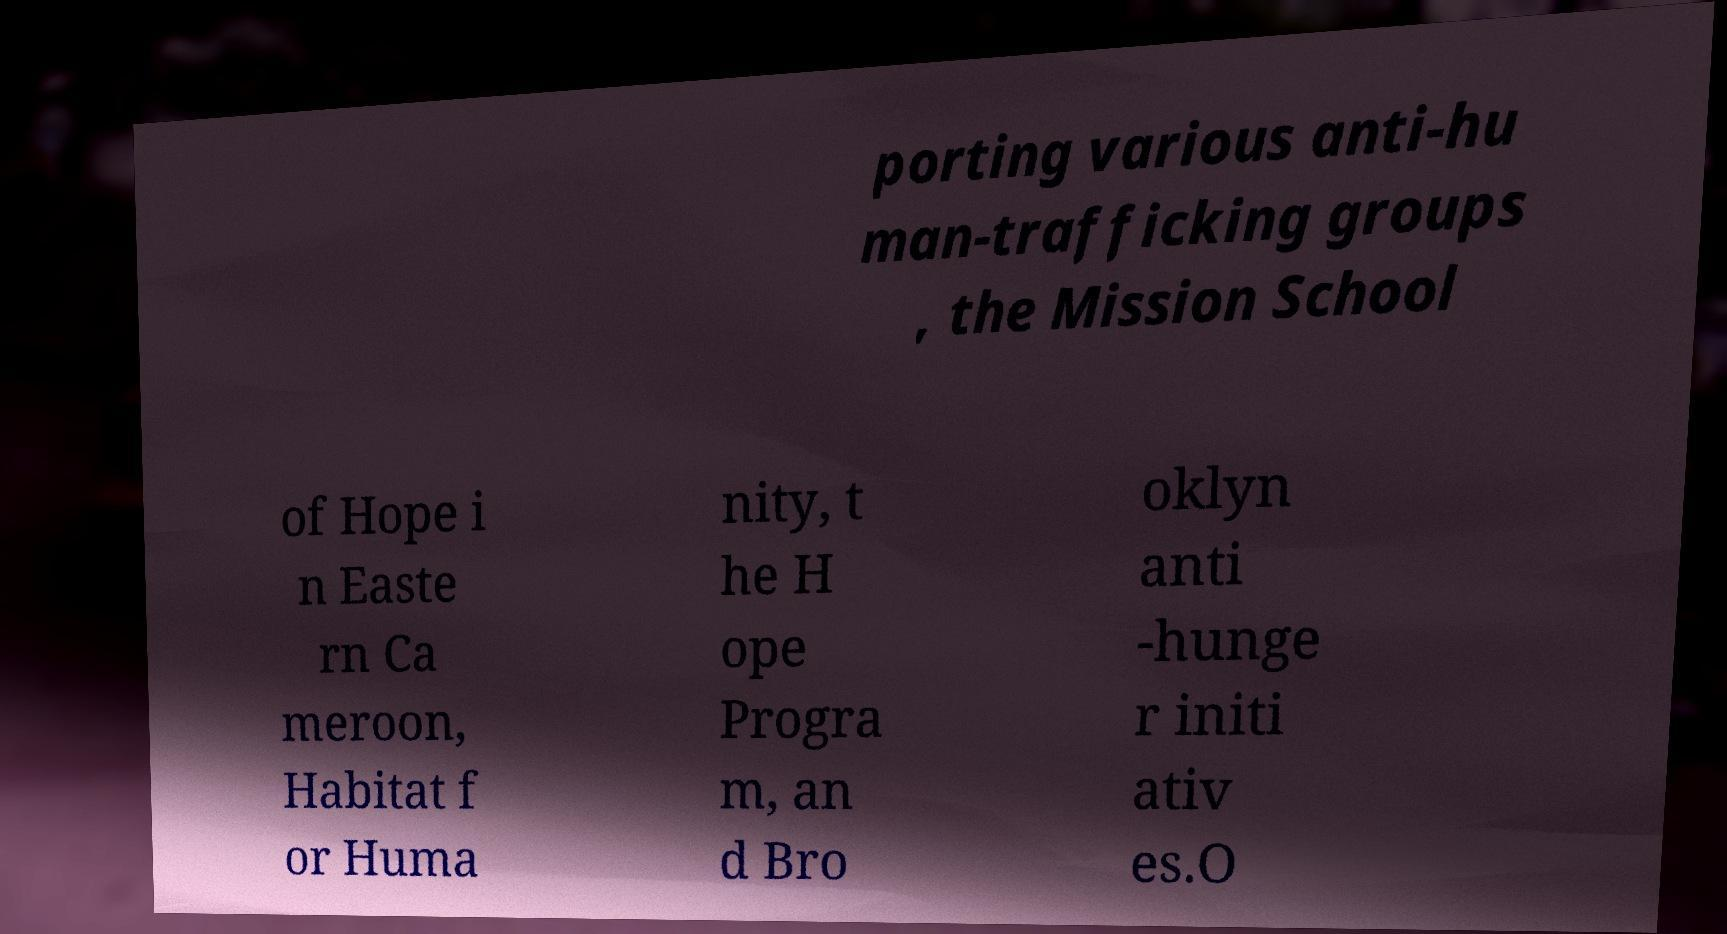Please read and relay the text visible in this image. What does it say? porting various anti-hu man-trafficking groups , the Mission School of Hope i n Easte rn Ca meroon, Habitat f or Huma nity, t he H ope Progra m, an d Bro oklyn anti -hunge r initi ativ es.O 